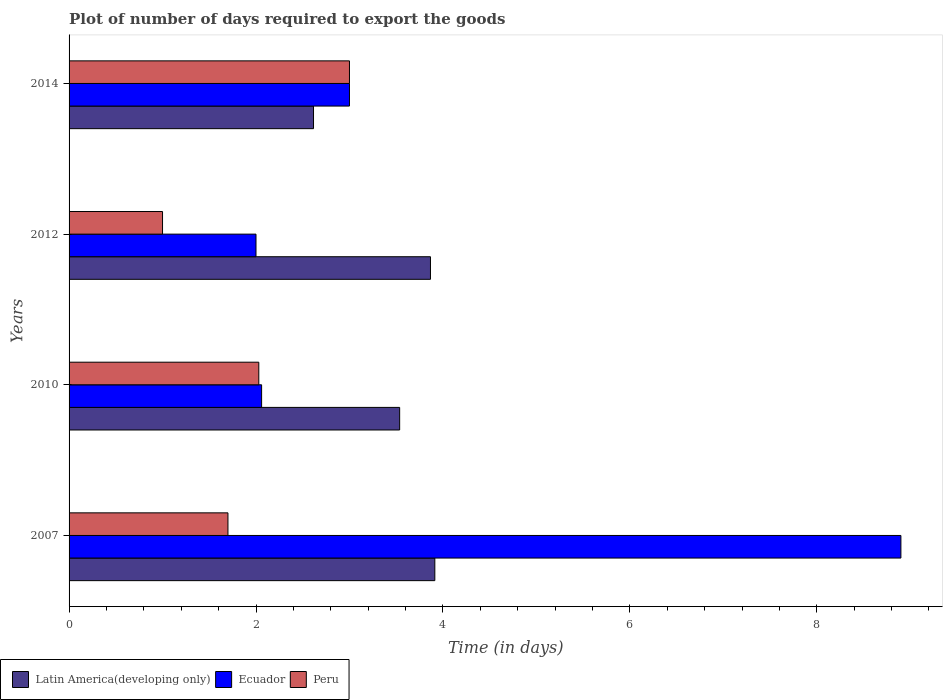How many groups of bars are there?
Keep it short and to the point. 4. Are the number of bars per tick equal to the number of legend labels?
Give a very brief answer. Yes. How many bars are there on the 4th tick from the bottom?
Your response must be concise. 3. What is the time required to export goods in Latin America(developing only) in 2007?
Offer a very short reply. 3.91. Across all years, what is the minimum time required to export goods in Ecuador?
Give a very brief answer. 2. In which year was the time required to export goods in Peru maximum?
Offer a terse response. 2014. In which year was the time required to export goods in Latin America(developing only) minimum?
Provide a short and direct response. 2014. What is the total time required to export goods in Ecuador in the graph?
Your answer should be compact. 15.96. What is the difference between the time required to export goods in Peru in 2010 and the time required to export goods in Ecuador in 2012?
Give a very brief answer. 0.03. What is the average time required to export goods in Ecuador per year?
Offer a terse response. 3.99. In the year 2012, what is the difference between the time required to export goods in Peru and time required to export goods in Latin America(developing only)?
Your answer should be very brief. -2.87. In how many years, is the time required to export goods in Peru greater than 8.4 days?
Your answer should be compact. 0. What is the ratio of the time required to export goods in Latin America(developing only) in 2007 to that in 2012?
Provide a succinct answer. 1.01. What is the difference between the highest and the second highest time required to export goods in Latin America(developing only)?
Offer a very short reply. 0.05. What is the difference between the highest and the lowest time required to export goods in Peru?
Keep it short and to the point. 2. In how many years, is the time required to export goods in Peru greater than the average time required to export goods in Peru taken over all years?
Keep it short and to the point. 2. What does the 2nd bar from the top in 2007 represents?
Offer a terse response. Ecuador. What does the 2nd bar from the bottom in 2007 represents?
Offer a very short reply. Ecuador. Is it the case that in every year, the sum of the time required to export goods in Ecuador and time required to export goods in Latin America(developing only) is greater than the time required to export goods in Peru?
Your response must be concise. Yes. Are all the bars in the graph horizontal?
Your answer should be very brief. Yes. How many years are there in the graph?
Your answer should be compact. 4. What is the difference between two consecutive major ticks on the X-axis?
Offer a very short reply. 2. Are the values on the major ticks of X-axis written in scientific E-notation?
Your answer should be compact. No. Does the graph contain grids?
Give a very brief answer. No. Where does the legend appear in the graph?
Ensure brevity in your answer.  Bottom left. How are the legend labels stacked?
Offer a terse response. Horizontal. What is the title of the graph?
Your response must be concise. Plot of number of days required to export the goods. Does "Indonesia" appear as one of the legend labels in the graph?
Your response must be concise. No. What is the label or title of the X-axis?
Your answer should be very brief. Time (in days). What is the Time (in days) in Latin America(developing only) in 2007?
Your answer should be compact. 3.91. What is the Time (in days) of Latin America(developing only) in 2010?
Your answer should be very brief. 3.54. What is the Time (in days) of Ecuador in 2010?
Keep it short and to the point. 2.06. What is the Time (in days) of Peru in 2010?
Your answer should be compact. 2.03. What is the Time (in days) of Latin America(developing only) in 2012?
Keep it short and to the point. 3.87. What is the Time (in days) of Ecuador in 2012?
Give a very brief answer. 2. What is the Time (in days) in Latin America(developing only) in 2014?
Keep it short and to the point. 2.62. What is the Time (in days) in Ecuador in 2014?
Offer a very short reply. 3. What is the Time (in days) of Peru in 2014?
Make the answer very short. 3. Across all years, what is the maximum Time (in days) in Latin America(developing only)?
Keep it short and to the point. 3.91. Across all years, what is the maximum Time (in days) in Ecuador?
Your answer should be very brief. 8.9. Across all years, what is the minimum Time (in days) in Latin America(developing only)?
Give a very brief answer. 2.62. What is the total Time (in days) in Latin America(developing only) in the graph?
Provide a short and direct response. 13.93. What is the total Time (in days) of Ecuador in the graph?
Your answer should be very brief. 15.96. What is the total Time (in days) of Peru in the graph?
Ensure brevity in your answer.  7.73. What is the difference between the Time (in days) in Latin America(developing only) in 2007 and that in 2010?
Keep it short and to the point. 0.38. What is the difference between the Time (in days) in Ecuador in 2007 and that in 2010?
Offer a terse response. 6.84. What is the difference between the Time (in days) in Peru in 2007 and that in 2010?
Your response must be concise. -0.33. What is the difference between the Time (in days) in Latin America(developing only) in 2007 and that in 2012?
Offer a terse response. 0.05. What is the difference between the Time (in days) of Latin America(developing only) in 2007 and that in 2014?
Offer a very short reply. 1.3. What is the difference between the Time (in days) of Peru in 2007 and that in 2014?
Ensure brevity in your answer.  -1.3. What is the difference between the Time (in days) in Latin America(developing only) in 2010 and that in 2012?
Provide a short and direct response. -0.33. What is the difference between the Time (in days) of Ecuador in 2010 and that in 2012?
Provide a succinct answer. 0.06. What is the difference between the Time (in days) of Peru in 2010 and that in 2012?
Make the answer very short. 1.03. What is the difference between the Time (in days) in Latin America(developing only) in 2010 and that in 2014?
Provide a succinct answer. 0.92. What is the difference between the Time (in days) of Ecuador in 2010 and that in 2014?
Your response must be concise. -0.94. What is the difference between the Time (in days) in Peru in 2010 and that in 2014?
Your response must be concise. -0.97. What is the difference between the Time (in days) in Latin America(developing only) in 2012 and that in 2014?
Give a very brief answer. 1.25. What is the difference between the Time (in days) of Peru in 2012 and that in 2014?
Offer a terse response. -2. What is the difference between the Time (in days) in Latin America(developing only) in 2007 and the Time (in days) in Ecuador in 2010?
Your answer should be very brief. 1.85. What is the difference between the Time (in days) in Latin America(developing only) in 2007 and the Time (in days) in Peru in 2010?
Offer a terse response. 1.88. What is the difference between the Time (in days) in Ecuador in 2007 and the Time (in days) in Peru in 2010?
Your answer should be compact. 6.87. What is the difference between the Time (in days) in Latin America(developing only) in 2007 and the Time (in days) in Ecuador in 2012?
Provide a succinct answer. 1.91. What is the difference between the Time (in days) of Latin America(developing only) in 2007 and the Time (in days) of Peru in 2012?
Provide a short and direct response. 2.91. What is the difference between the Time (in days) of Latin America(developing only) in 2007 and the Time (in days) of Ecuador in 2014?
Make the answer very short. 0.91. What is the difference between the Time (in days) of Latin America(developing only) in 2007 and the Time (in days) of Peru in 2014?
Offer a very short reply. 0.91. What is the difference between the Time (in days) in Latin America(developing only) in 2010 and the Time (in days) in Ecuador in 2012?
Your answer should be very brief. 1.54. What is the difference between the Time (in days) in Latin America(developing only) in 2010 and the Time (in days) in Peru in 2012?
Your response must be concise. 2.54. What is the difference between the Time (in days) of Ecuador in 2010 and the Time (in days) of Peru in 2012?
Your answer should be compact. 1.06. What is the difference between the Time (in days) in Latin America(developing only) in 2010 and the Time (in days) in Ecuador in 2014?
Offer a terse response. 0.54. What is the difference between the Time (in days) of Latin America(developing only) in 2010 and the Time (in days) of Peru in 2014?
Your answer should be compact. 0.54. What is the difference between the Time (in days) of Ecuador in 2010 and the Time (in days) of Peru in 2014?
Ensure brevity in your answer.  -0.94. What is the difference between the Time (in days) in Latin America(developing only) in 2012 and the Time (in days) in Ecuador in 2014?
Your answer should be compact. 0.87. What is the difference between the Time (in days) in Latin America(developing only) in 2012 and the Time (in days) in Peru in 2014?
Your response must be concise. 0.87. What is the difference between the Time (in days) in Ecuador in 2012 and the Time (in days) in Peru in 2014?
Your answer should be very brief. -1. What is the average Time (in days) of Latin America(developing only) per year?
Offer a very short reply. 3.48. What is the average Time (in days) of Ecuador per year?
Ensure brevity in your answer.  3.99. What is the average Time (in days) in Peru per year?
Offer a very short reply. 1.93. In the year 2007, what is the difference between the Time (in days) of Latin America(developing only) and Time (in days) of Ecuador?
Ensure brevity in your answer.  -4.99. In the year 2007, what is the difference between the Time (in days) in Latin America(developing only) and Time (in days) in Peru?
Provide a succinct answer. 2.21. In the year 2007, what is the difference between the Time (in days) of Ecuador and Time (in days) of Peru?
Your answer should be very brief. 7.2. In the year 2010, what is the difference between the Time (in days) of Latin America(developing only) and Time (in days) of Ecuador?
Your response must be concise. 1.48. In the year 2010, what is the difference between the Time (in days) of Latin America(developing only) and Time (in days) of Peru?
Provide a succinct answer. 1.51. In the year 2010, what is the difference between the Time (in days) of Ecuador and Time (in days) of Peru?
Provide a short and direct response. 0.03. In the year 2012, what is the difference between the Time (in days) in Latin America(developing only) and Time (in days) in Ecuador?
Your answer should be compact. 1.87. In the year 2012, what is the difference between the Time (in days) of Latin America(developing only) and Time (in days) of Peru?
Ensure brevity in your answer.  2.87. In the year 2014, what is the difference between the Time (in days) in Latin America(developing only) and Time (in days) in Ecuador?
Provide a short and direct response. -0.38. In the year 2014, what is the difference between the Time (in days) of Latin America(developing only) and Time (in days) of Peru?
Ensure brevity in your answer.  -0.38. In the year 2014, what is the difference between the Time (in days) in Ecuador and Time (in days) in Peru?
Offer a very short reply. 0. What is the ratio of the Time (in days) of Latin America(developing only) in 2007 to that in 2010?
Give a very brief answer. 1.11. What is the ratio of the Time (in days) of Ecuador in 2007 to that in 2010?
Give a very brief answer. 4.32. What is the ratio of the Time (in days) of Peru in 2007 to that in 2010?
Keep it short and to the point. 0.84. What is the ratio of the Time (in days) of Latin America(developing only) in 2007 to that in 2012?
Keep it short and to the point. 1.01. What is the ratio of the Time (in days) of Ecuador in 2007 to that in 2012?
Make the answer very short. 4.45. What is the ratio of the Time (in days) of Latin America(developing only) in 2007 to that in 2014?
Keep it short and to the point. 1.5. What is the ratio of the Time (in days) in Ecuador in 2007 to that in 2014?
Your response must be concise. 2.97. What is the ratio of the Time (in days) in Peru in 2007 to that in 2014?
Keep it short and to the point. 0.57. What is the ratio of the Time (in days) of Latin America(developing only) in 2010 to that in 2012?
Keep it short and to the point. 0.91. What is the ratio of the Time (in days) of Ecuador in 2010 to that in 2012?
Give a very brief answer. 1.03. What is the ratio of the Time (in days) of Peru in 2010 to that in 2012?
Your response must be concise. 2.03. What is the ratio of the Time (in days) in Latin America(developing only) in 2010 to that in 2014?
Give a very brief answer. 1.35. What is the ratio of the Time (in days) of Ecuador in 2010 to that in 2014?
Offer a very short reply. 0.69. What is the ratio of the Time (in days) in Peru in 2010 to that in 2014?
Give a very brief answer. 0.68. What is the ratio of the Time (in days) of Latin America(developing only) in 2012 to that in 2014?
Ensure brevity in your answer.  1.48. What is the difference between the highest and the second highest Time (in days) of Latin America(developing only)?
Your response must be concise. 0.05. What is the difference between the highest and the second highest Time (in days) in Ecuador?
Provide a short and direct response. 5.9. What is the difference between the highest and the lowest Time (in days) of Latin America(developing only)?
Give a very brief answer. 1.3. What is the difference between the highest and the lowest Time (in days) in Ecuador?
Provide a succinct answer. 6.9. 